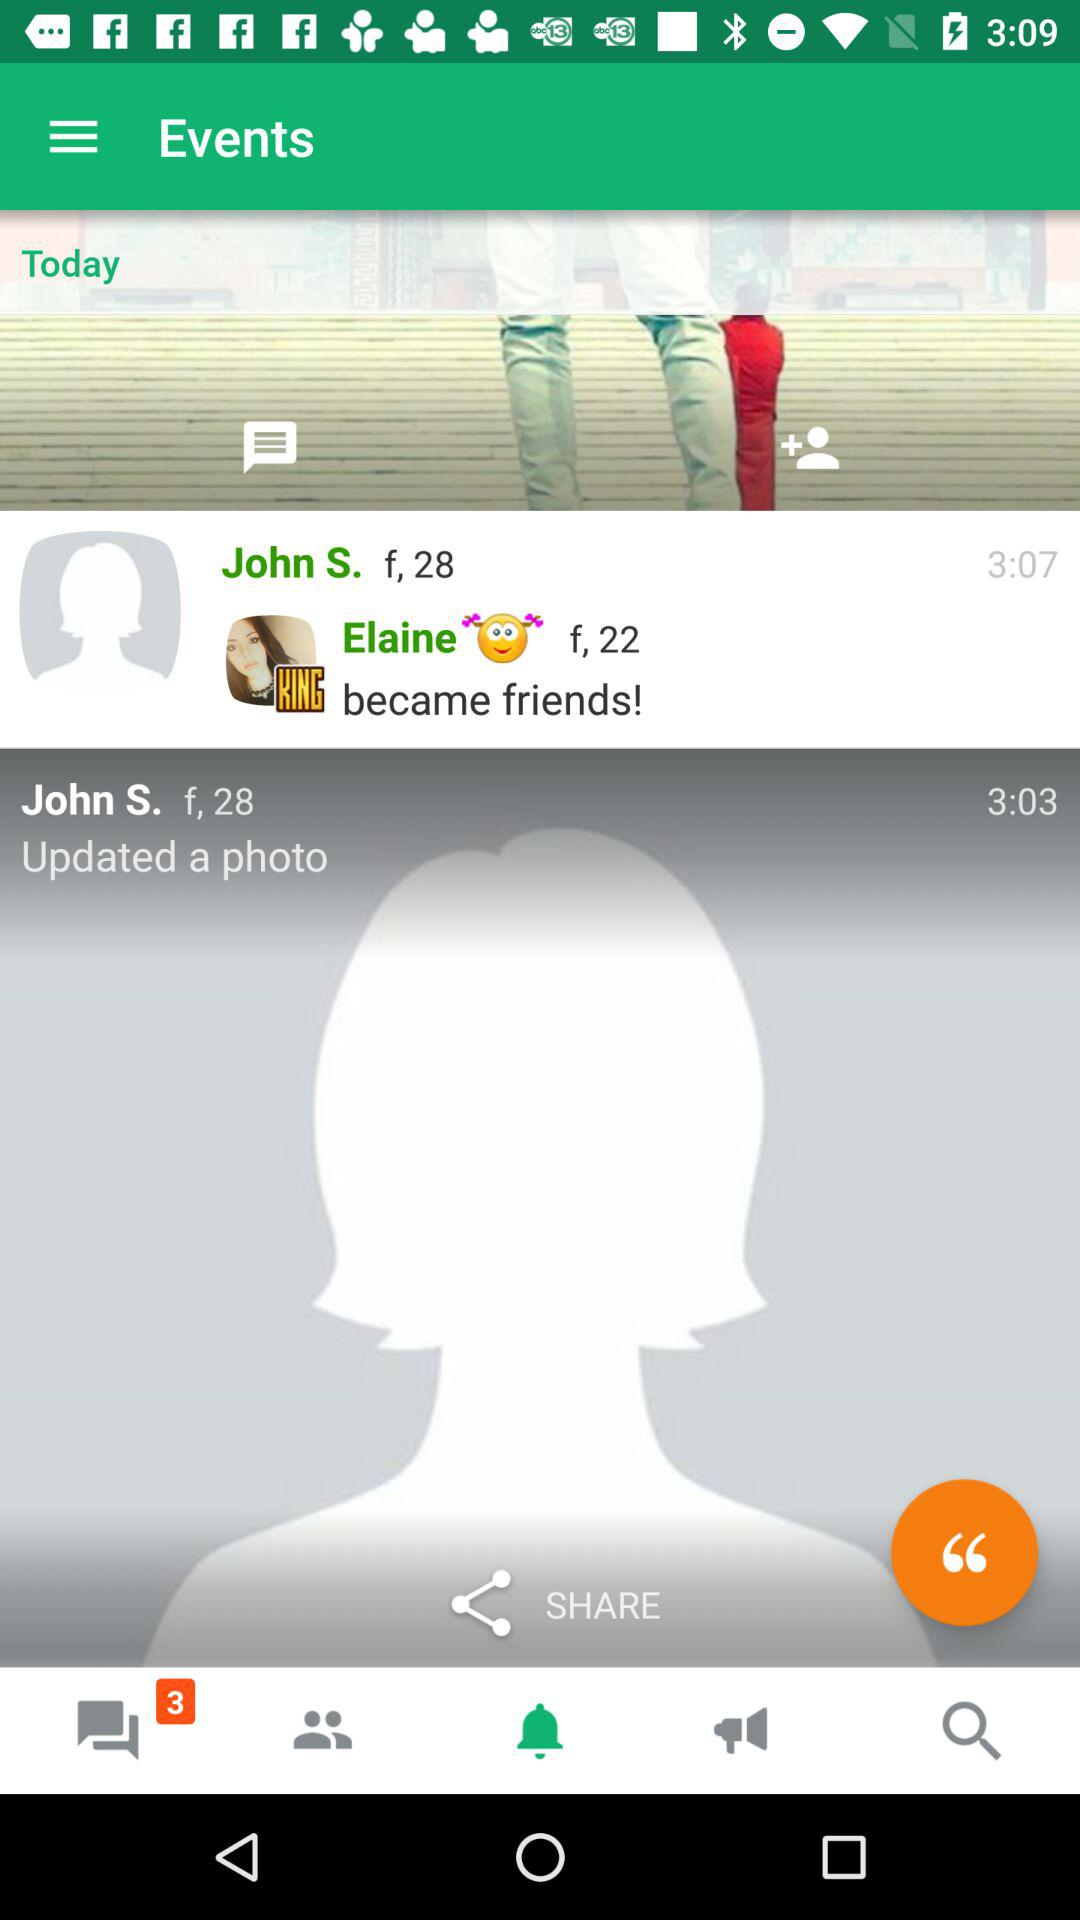What is the age of John S.? The age of John S. is 28. 